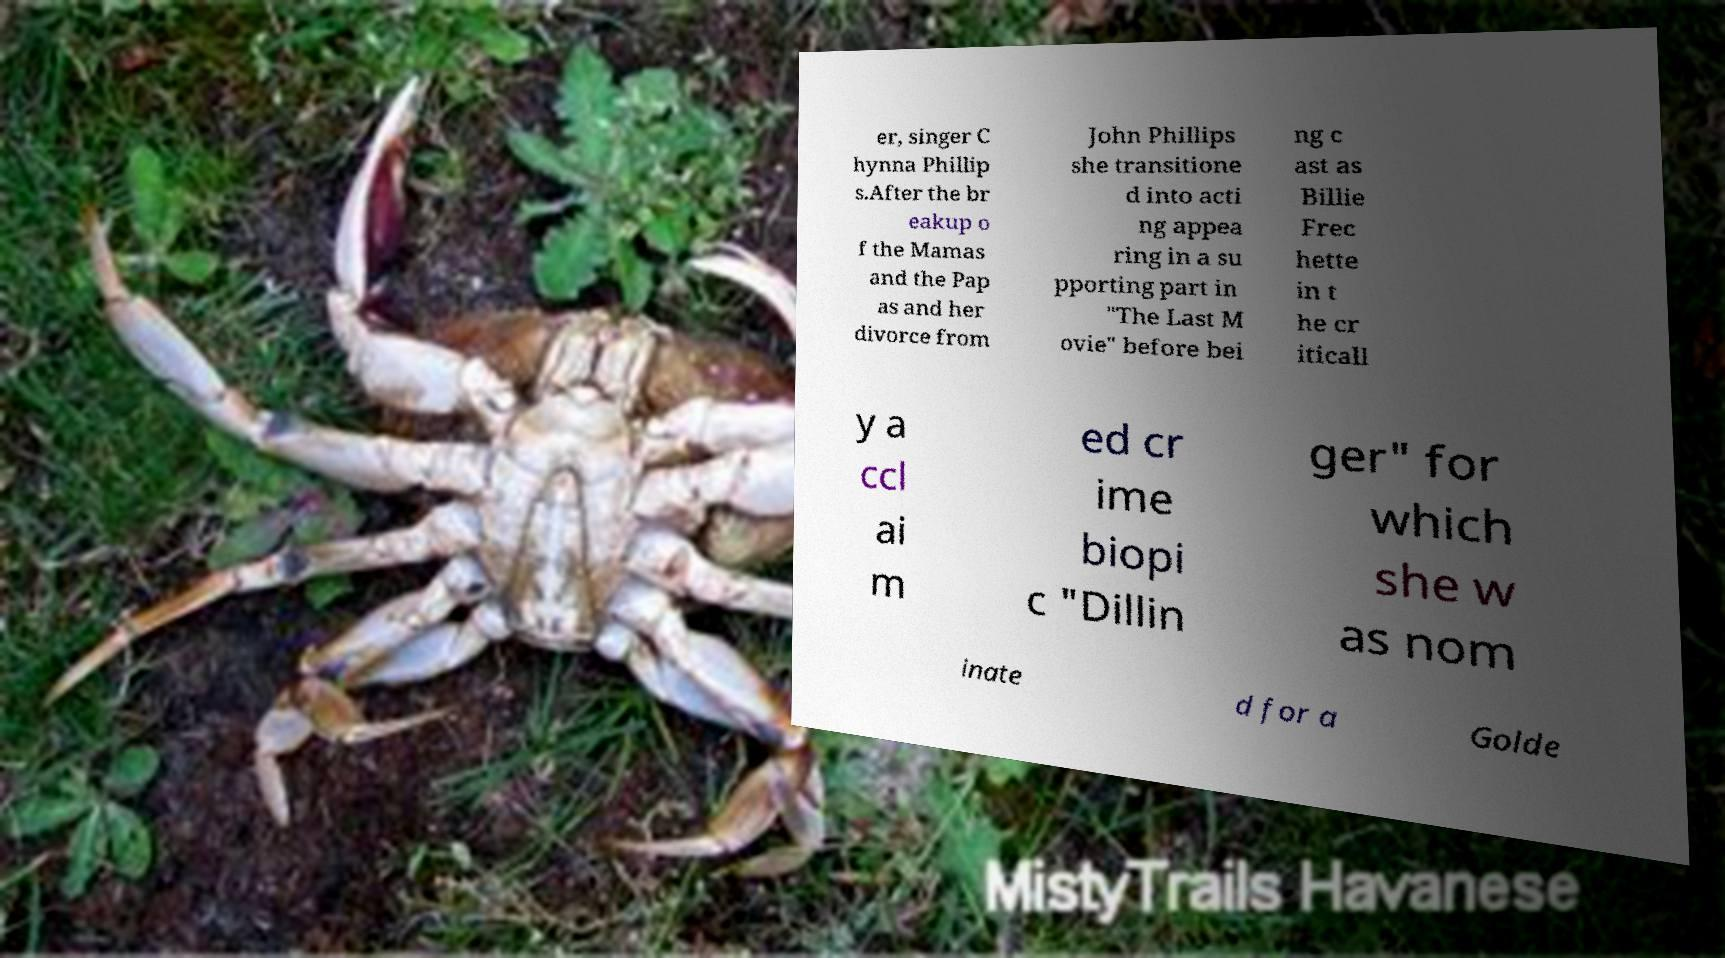I need the written content from this picture converted into text. Can you do that? er, singer C hynna Phillip s.After the br eakup o f the Mamas and the Pap as and her divorce from John Phillips she transitione d into acti ng appea ring in a su pporting part in "The Last M ovie" before bei ng c ast as Billie Frec hette in t he cr iticall y a ccl ai m ed cr ime biopi c "Dillin ger" for which she w as nom inate d for a Golde 